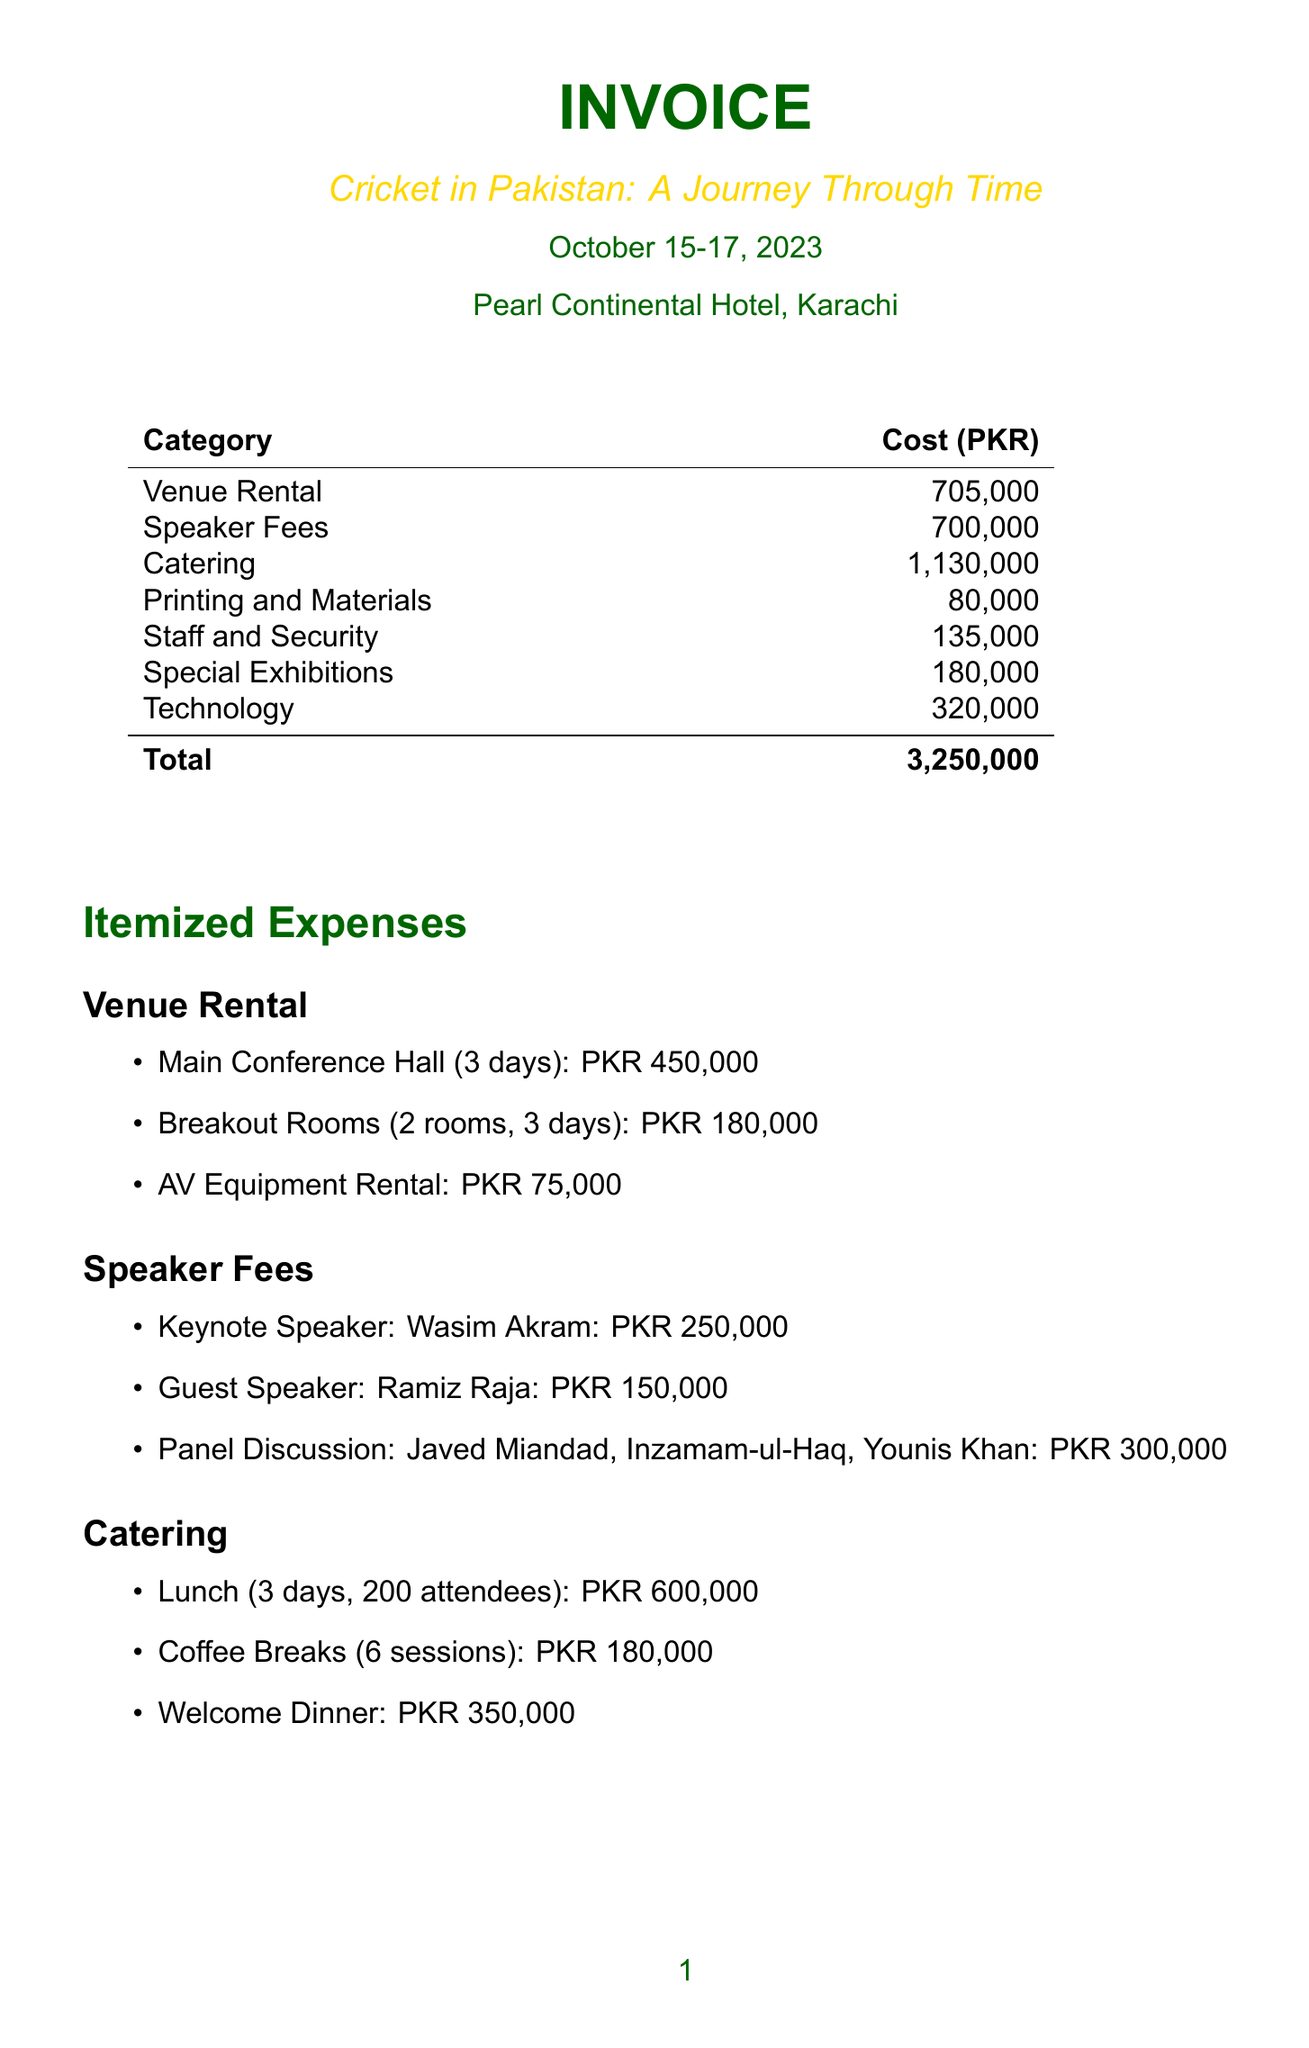What is the title of the symposium? The title of the symposium is mentioned at the top of the document.
Answer: Cricket in Pakistan: A Journey Through Time What is the total cost of organizing the symposium? The total cost is presented at the bottom of the invoice.
Answer: PKR 3,250,000 How much was spent on speaker fees? The speaker fees total is calculated and shown amongst the itemized expenses.
Answer: PKR 700,000 What is the rental cost for the Main Conference Hall? The rental cost for the Main Conference Hall is specifically listed under the venue rental section.
Answer: PKR 450,000 How many attendees were expected for lunch? The expected number of attendees for lunch is indicated in the catering section.
Answer: 200 What category has the highest expense? The highest expense category can be determined by comparing the costs listed.
Answer: Catering How much did the technology expenses total? The total technology expenses can be found in the itemized section of the document.
Answer: PKR 320,000 Who was the keynote speaker? The keynote speaker is specified among the speaker fees.
Answer: Wasim Akram How many days was the symposium held? The duration of the symposium is provided in the date section of the document.
Answer: 3 days What type of venue was used for the symposium? The type of venue is mentioned at the beginning in the venue section.
Answer: Pearl Continental Hotel, Karachi 